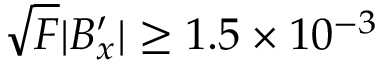<formula> <loc_0><loc_0><loc_500><loc_500>\sqrt { F } | B _ { x } ^ { \prime } | \geq 1 . 5 \times 1 0 ^ { - 3 }</formula> 